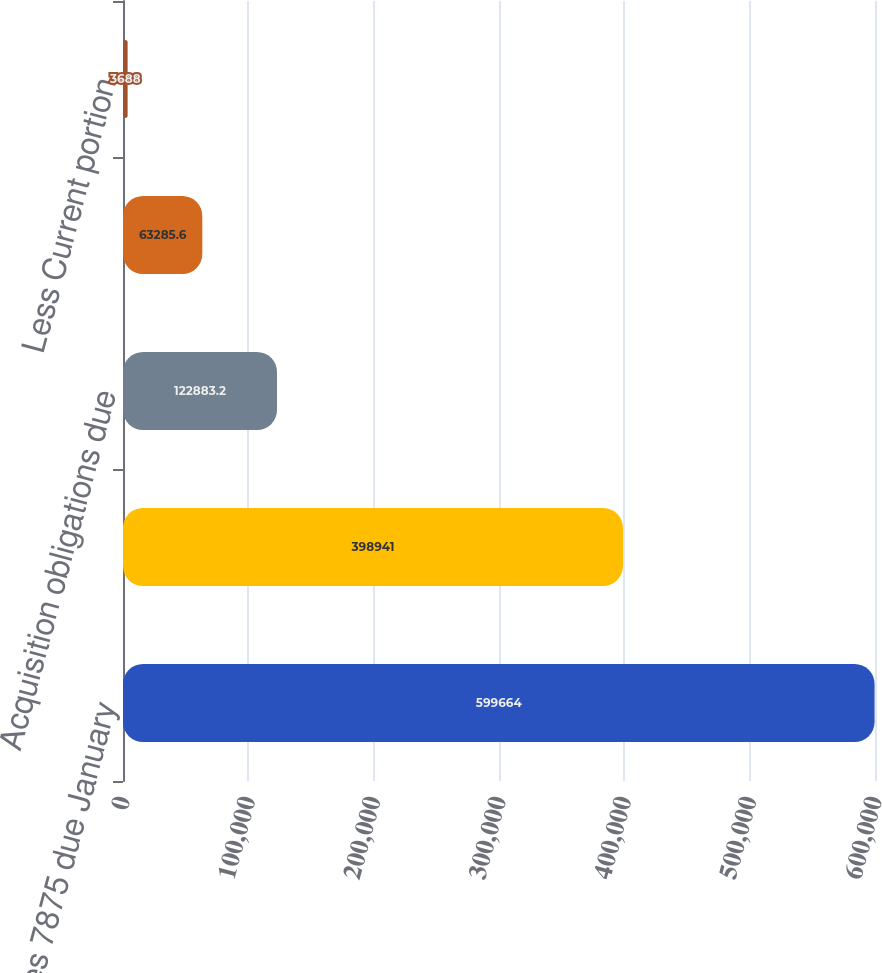Convert chart to OTSL. <chart><loc_0><loc_0><loc_500><loc_500><bar_chart><fcel>Senior Notes 7875 due January<fcel>Senior Notes 5125 due October<fcel>Acquisition obligations due<fcel>Capital lease obligations<fcel>Less Current portion<nl><fcel>599664<fcel>398941<fcel>122883<fcel>63285.6<fcel>3688<nl></chart> 